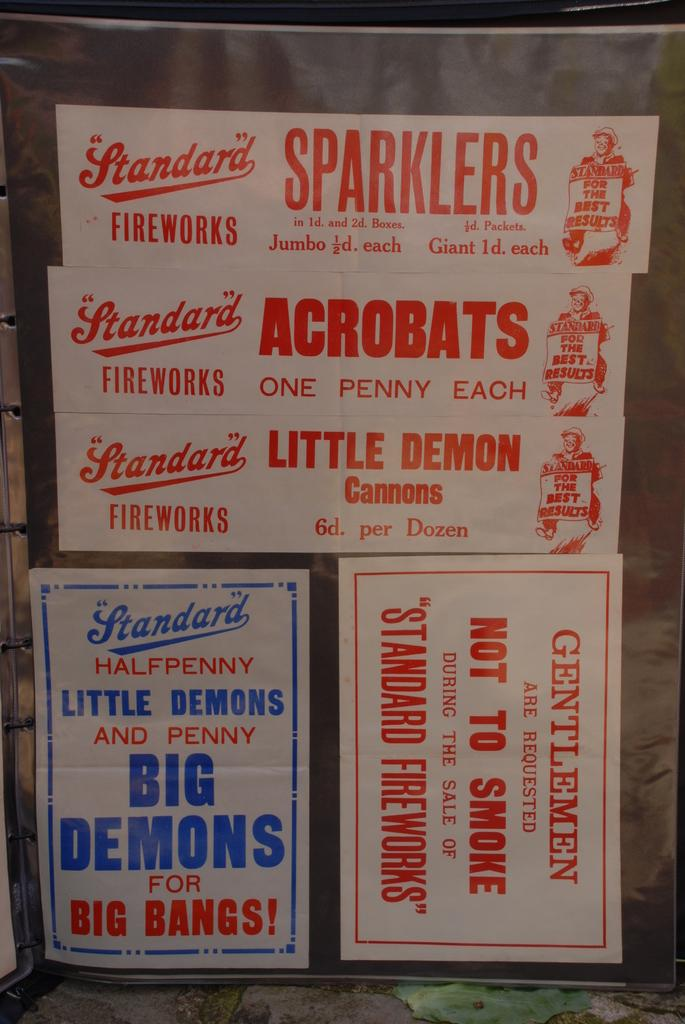<image>
Describe the image concisely. Different varieties of signs that advertise Standard Fireworks. 